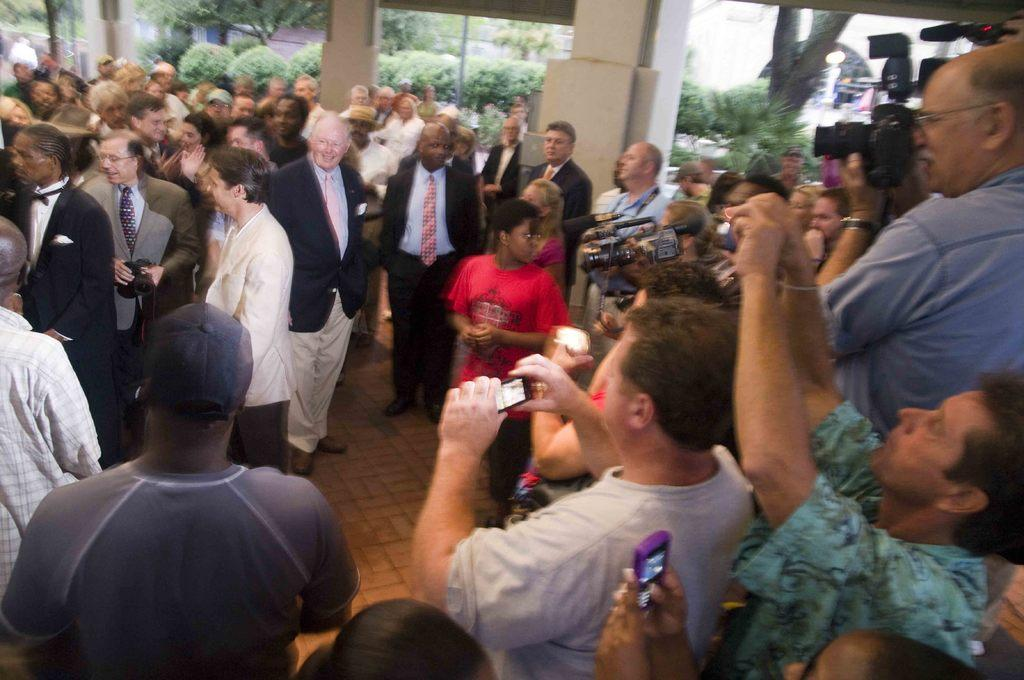What is the main focus of the image? The main focus of the image is the many people in the center. Can you describe the background of the image? The background of the image includes trees. How many birds are sitting on the gate in the image? There is no gate or birds present in the image. 